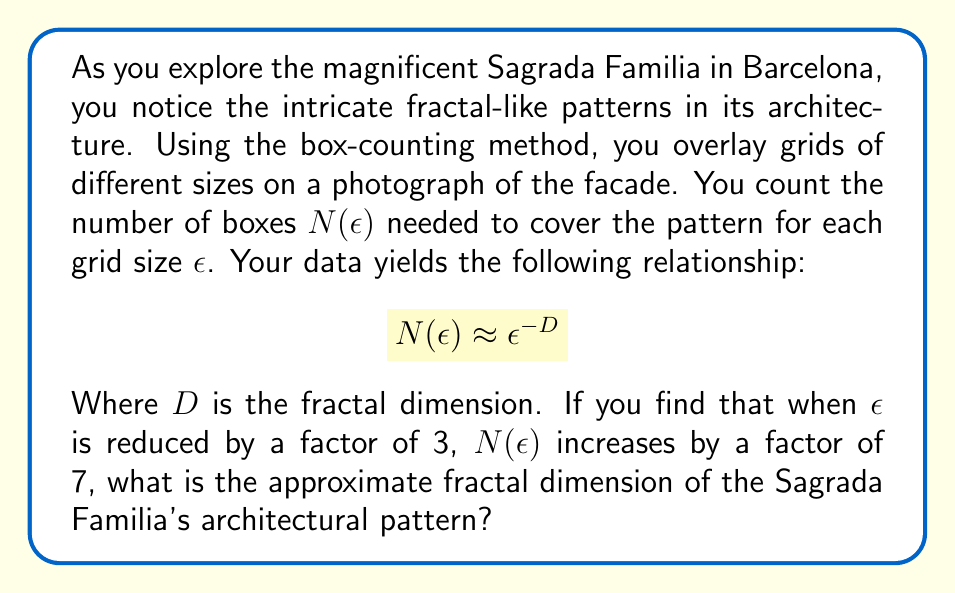What is the answer to this math problem? Let's approach this step-by-step:

1) The fractal dimension $D$ is defined by the relationship:

   $$N(\epsilon) \approx \epsilon^{-D}$$

2) We're told that when $\epsilon$ is reduced by a factor of 3, $N(\epsilon)$ increases by a factor of 7. Let's express this mathematically:

   $$\frac{N(\epsilon/3)}{N(\epsilon)} = 7$$

3) Using the relationship from step 1, we can write:

   $$\frac{(\epsilon/3)^{-D}}{\epsilon^{-D}} = 7$$

4) Simplify the left side:

   $$3^D = 7$$

5) To solve for $D$, we take the logarithm of both sides:

   $$D \log(3) = \log(7)$$

6) Now we can solve for $D$:

   $$D = \frac{\log(7)}{\log(3)}$$

7) Using a calculator or computer, we can evaluate this:

   $$D \approx 1.7712$$

This value represents the approximate fractal dimension of the architectural pattern.
Answer: $D \approx 1.7712$ 